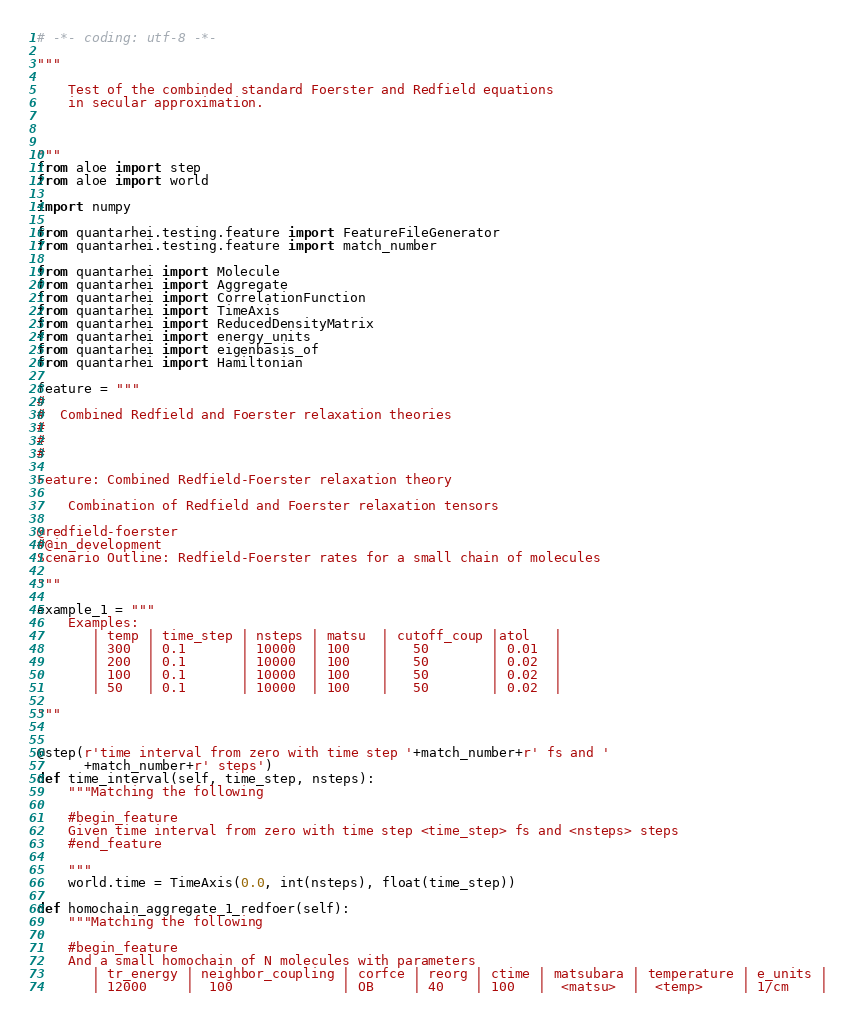<code> <loc_0><loc_0><loc_500><loc_500><_Python_># -*- coding: utf-8 -*-

"""

    Test of the combinded standard Foerster and Redfield equations
    in secular approximation.
    


"""
from aloe import step
from aloe import world

import numpy

from quantarhei.testing.feature import FeatureFileGenerator
from quantarhei.testing.feature import match_number 

from quantarhei import Molecule
from quantarhei import Aggregate
from quantarhei import CorrelationFunction
from quantarhei import TimeAxis
from quantarhei import ReducedDensityMatrix
from quantarhei import energy_units
from quantarhei import eigenbasis_of
from quantarhei import Hamiltonian

feature = """
#
#  Combined Redfield and Foerster relaxation theories 
#
#
#

Feature: Combined Redfield-Foerster relaxation theory 

    Combination of Redfield and Foerster relaxation tensors 

@redfield-foerster
#@in_development
Scenario Outline: Redfield-Foerster rates for a small chain of molecules

"""

example_1 = """
    Examples:
       | temp | time_step | nsteps | matsu  | cutoff_coup |atol   |
       | 300  | 0.1       | 10000  | 100    |   50        | 0.01  |
       | 200  | 0.1       | 10000  | 100    |   50        | 0.02  |
       | 100  | 0.1       | 10000  | 100    |   50        | 0.02  |
       | 50   | 0.1       | 10000  | 100    |   50        | 0.02  |

"""


@step(r'time interval from zero with time step '+match_number+r' fs and '
      +match_number+r' steps')
def time_interval(self, time_step, nsteps):
    """Matching the following
    
    #begin_feature    
    Given time interval from zero with time step <time_step> fs and <nsteps> steps
    #end_feature
    
    """
    world.time = TimeAxis(0.0, int(nsteps), float(time_step))
    
def homochain_aggregate_1_redfoer(self):
    """Matching the following 
    
    #begin_feature
    And a small homochain of N molecules with parameters
       | tr_energy | neighbor_coupling | corfce | reorg | ctime | matsubara | temperature | e_units |
       | 12000     |  100              | OB     | 40    | 100   |  <matsu>  |  <temp>     | 1/cm    |</code> 